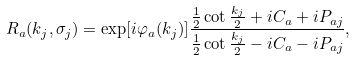<formula> <loc_0><loc_0><loc_500><loc_500>R _ { a } ( k _ { j } , \sigma _ { j } ) = \exp [ i \varphi _ { a } ( k _ { j } ) ] \frac { \frac { 1 } { 2 } \cot \frac { k _ { j } } 2 + i C _ { a } + i P _ { a j } } { \frac { 1 } { 2 } \cot \frac { k _ { j } } 2 - i C _ { a } - i P _ { a j } } ,</formula> 